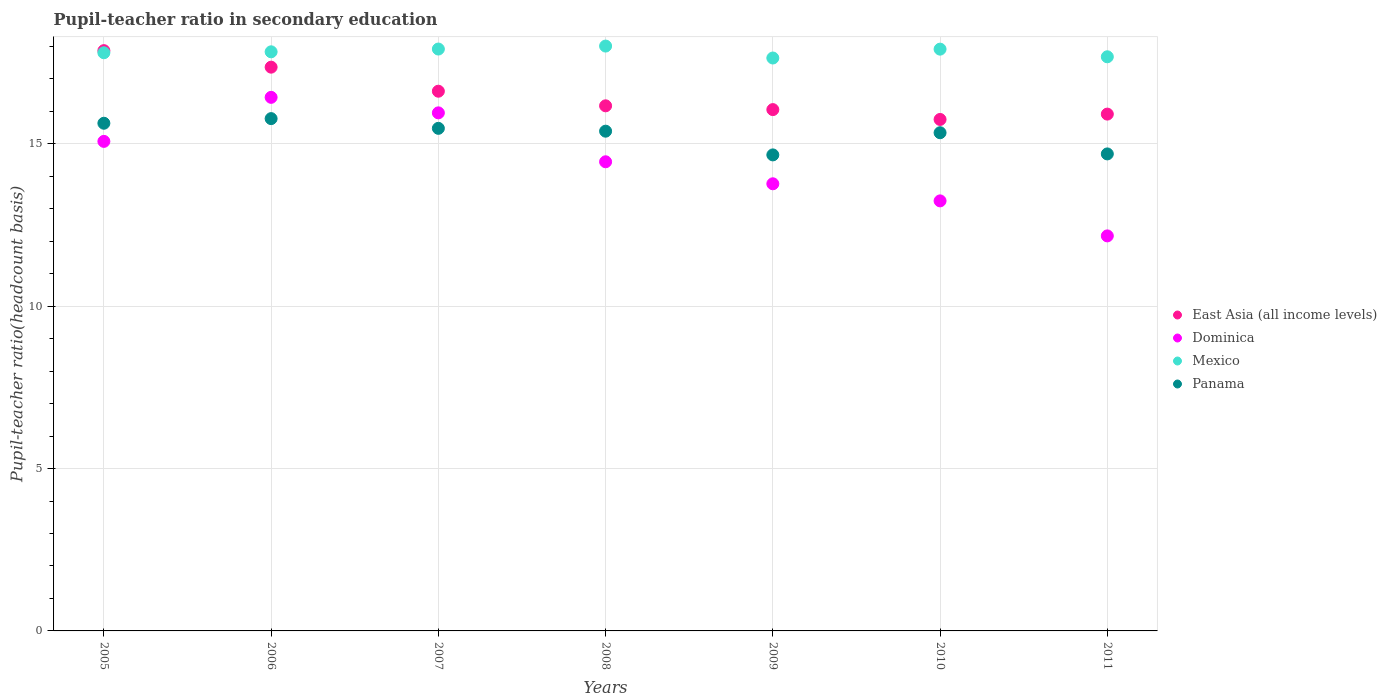What is the pupil-teacher ratio in secondary education in Dominica in 2005?
Offer a very short reply. 15.07. Across all years, what is the maximum pupil-teacher ratio in secondary education in Dominica?
Your answer should be very brief. 16.43. Across all years, what is the minimum pupil-teacher ratio in secondary education in Mexico?
Offer a very short reply. 17.64. What is the total pupil-teacher ratio in secondary education in Mexico in the graph?
Your answer should be very brief. 124.78. What is the difference between the pupil-teacher ratio in secondary education in East Asia (all income levels) in 2008 and that in 2011?
Your response must be concise. 0.26. What is the difference between the pupil-teacher ratio in secondary education in Dominica in 2006 and the pupil-teacher ratio in secondary education in Mexico in 2011?
Make the answer very short. -1.25. What is the average pupil-teacher ratio in secondary education in Dominica per year?
Your answer should be compact. 14.44. In the year 2010, what is the difference between the pupil-teacher ratio in secondary education in Dominica and pupil-teacher ratio in secondary education in Mexico?
Provide a succinct answer. -4.67. In how many years, is the pupil-teacher ratio in secondary education in Panama greater than 4?
Your response must be concise. 7. What is the ratio of the pupil-teacher ratio in secondary education in Dominica in 2007 to that in 2009?
Offer a terse response. 1.16. Is the pupil-teacher ratio in secondary education in Panama in 2008 less than that in 2011?
Your answer should be compact. No. Is the difference between the pupil-teacher ratio in secondary education in Dominica in 2008 and 2010 greater than the difference between the pupil-teacher ratio in secondary education in Mexico in 2008 and 2010?
Offer a terse response. Yes. What is the difference between the highest and the second highest pupil-teacher ratio in secondary education in East Asia (all income levels)?
Keep it short and to the point. 0.51. What is the difference between the highest and the lowest pupil-teacher ratio in secondary education in Mexico?
Offer a very short reply. 0.37. In how many years, is the pupil-teacher ratio in secondary education in Dominica greater than the average pupil-teacher ratio in secondary education in Dominica taken over all years?
Give a very brief answer. 4. Is it the case that in every year, the sum of the pupil-teacher ratio in secondary education in Dominica and pupil-teacher ratio in secondary education in East Asia (all income levels)  is greater than the sum of pupil-teacher ratio in secondary education in Mexico and pupil-teacher ratio in secondary education in Panama?
Offer a terse response. No. Does the pupil-teacher ratio in secondary education in Mexico monotonically increase over the years?
Your answer should be very brief. No. Is the pupil-teacher ratio in secondary education in Dominica strictly less than the pupil-teacher ratio in secondary education in East Asia (all income levels) over the years?
Offer a terse response. Yes. How many dotlines are there?
Offer a terse response. 4. Where does the legend appear in the graph?
Make the answer very short. Center right. What is the title of the graph?
Provide a short and direct response. Pupil-teacher ratio in secondary education. Does "Congo (Republic)" appear as one of the legend labels in the graph?
Your response must be concise. No. What is the label or title of the X-axis?
Keep it short and to the point. Years. What is the label or title of the Y-axis?
Provide a short and direct response. Pupil-teacher ratio(headcount basis). What is the Pupil-teacher ratio(headcount basis) in East Asia (all income levels) in 2005?
Your answer should be compact. 17.87. What is the Pupil-teacher ratio(headcount basis) of Dominica in 2005?
Ensure brevity in your answer.  15.07. What is the Pupil-teacher ratio(headcount basis) of Mexico in 2005?
Provide a succinct answer. 17.8. What is the Pupil-teacher ratio(headcount basis) of Panama in 2005?
Your answer should be compact. 15.63. What is the Pupil-teacher ratio(headcount basis) in East Asia (all income levels) in 2006?
Ensure brevity in your answer.  17.36. What is the Pupil-teacher ratio(headcount basis) in Dominica in 2006?
Your response must be concise. 16.43. What is the Pupil-teacher ratio(headcount basis) of Mexico in 2006?
Make the answer very short. 17.83. What is the Pupil-teacher ratio(headcount basis) in Panama in 2006?
Provide a succinct answer. 15.77. What is the Pupil-teacher ratio(headcount basis) in East Asia (all income levels) in 2007?
Provide a short and direct response. 16.62. What is the Pupil-teacher ratio(headcount basis) of Dominica in 2007?
Ensure brevity in your answer.  15.95. What is the Pupil-teacher ratio(headcount basis) in Mexico in 2007?
Give a very brief answer. 17.92. What is the Pupil-teacher ratio(headcount basis) of Panama in 2007?
Make the answer very short. 15.47. What is the Pupil-teacher ratio(headcount basis) in East Asia (all income levels) in 2008?
Your answer should be compact. 16.17. What is the Pupil-teacher ratio(headcount basis) of Dominica in 2008?
Keep it short and to the point. 14.44. What is the Pupil-teacher ratio(headcount basis) in Mexico in 2008?
Ensure brevity in your answer.  18.01. What is the Pupil-teacher ratio(headcount basis) of Panama in 2008?
Your response must be concise. 15.39. What is the Pupil-teacher ratio(headcount basis) of East Asia (all income levels) in 2009?
Ensure brevity in your answer.  16.05. What is the Pupil-teacher ratio(headcount basis) in Dominica in 2009?
Make the answer very short. 13.77. What is the Pupil-teacher ratio(headcount basis) of Mexico in 2009?
Make the answer very short. 17.64. What is the Pupil-teacher ratio(headcount basis) in Panama in 2009?
Provide a succinct answer. 14.66. What is the Pupil-teacher ratio(headcount basis) of East Asia (all income levels) in 2010?
Your answer should be very brief. 15.75. What is the Pupil-teacher ratio(headcount basis) in Dominica in 2010?
Offer a very short reply. 13.24. What is the Pupil-teacher ratio(headcount basis) in Mexico in 2010?
Make the answer very short. 17.91. What is the Pupil-teacher ratio(headcount basis) in Panama in 2010?
Provide a short and direct response. 15.34. What is the Pupil-teacher ratio(headcount basis) of East Asia (all income levels) in 2011?
Make the answer very short. 15.91. What is the Pupil-teacher ratio(headcount basis) in Dominica in 2011?
Keep it short and to the point. 12.16. What is the Pupil-teacher ratio(headcount basis) of Mexico in 2011?
Keep it short and to the point. 17.68. What is the Pupil-teacher ratio(headcount basis) of Panama in 2011?
Offer a very short reply. 14.69. Across all years, what is the maximum Pupil-teacher ratio(headcount basis) of East Asia (all income levels)?
Give a very brief answer. 17.87. Across all years, what is the maximum Pupil-teacher ratio(headcount basis) of Dominica?
Keep it short and to the point. 16.43. Across all years, what is the maximum Pupil-teacher ratio(headcount basis) in Mexico?
Provide a short and direct response. 18.01. Across all years, what is the maximum Pupil-teacher ratio(headcount basis) of Panama?
Provide a succinct answer. 15.77. Across all years, what is the minimum Pupil-teacher ratio(headcount basis) of East Asia (all income levels)?
Offer a terse response. 15.75. Across all years, what is the minimum Pupil-teacher ratio(headcount basis) in Dominica?
Ensure brevity in your answer.  12.16. Across all years, what is the minimum Pupil-teacher ratio(headcount basis) of Mexico?
Your answer should be very brief. 17.64. Across all years, what is the minimum Pupil-teacher ratio(headcount basis) in Panama?
Your answer should be compact. 14.66. What is the total Pupil-teacher ratio(headcount basis) of East Asia (all income levels) in the graph?
Make the answer very short. 115.72. What is the total Pupil-teacher ratio(headcount basis) of Dominica in the graph?
Offer a terse response. 101.07. What is the total Pupil-teacher ratio(headcount basis) of Mexico in the graph?
Make the answer very short. 124.78. What is the total Pupil-teacher ratio(headcount basis) in Panama in the graph?
Provide a short and direct response. 106.95. What is the difference between the Pupil-teacher ratio(headcount basis) of East Asia (all income levels) in 2005 and that in 2006?
Keep it short and to the point. 0.51. What is the difference between the Pupil-teacher ratio(headcount basis) of Dominica in 2005 and that in 2006?
Offer a very short reply. -1.36. What is the difference between the Pupil-teacher ratio(headcount basis) of Mexico in 2005 and that in 2006?
Make the answer very short. -0.03. What is the difference between the Pupil-teacher ratio(headcount basis) in Panama in 2005 and that in 2006?
Give a very brief answer. -0.14. What is the difference between the Pupil-teacher ratio(headcount basis) of East Asia (all income levels) in 2005 and that in 2007?
Make the answer very short. 1.25. What is the difference between the Pupil-teacher ratio(headcount basis) in Dominica in 2005 and that in 2007?
Your response must be concise. -0.88. What is the difference between the Pupil-teacher ratio(headcount basis) of Mexico in 2005 and that in 2007?
Provide a succinct answer. -0.11. What is the difference between the Pupil-teacher ratio(headcount basis) in Panama in 2005 and that in 2007?
Your answer should be very brief. 0.16. What is the difference between the Pupil-teacher ratio(headcount basis) of East Asia (all income levels) in 2005 and that in 2008?
Give a very brief answer. 1.7. What is the difference between the Pupil-teacher ratio(headcount basis) of Dominica in 2005 and that in 2008?
Ensure brevity in your answer.  0.63. What is the difference between the Pupil-teacher ratio(headcount basis) of Mexico in 2005 and that in 2008?
Offer a very short reply. -0.21. What is the difference between the Pupil-teacher ratio(headcount basis) of Panama in 2005 and that in 2008?
Keep it short and to the point. 0.24. What is the difference between the Pupil-teacher ratio(headcount basis) of East Asia (all income levels) in 2005 and that in 2009?
Your response must be concise. 1.82. What is the difference between the Pupil-teacher ratio(headcount basis) in Dominica in 2005 and that in 2009?
Your response must be concise. 1.31. What is the difference between the Pupil-teacher ratio(headcount basis) of Mexico in 2005 and that in 2009?
Your response must be concise. 0.16. What is the difference between the Pupil-teacher ratio(headcount basis) in Panama in 2005 and that in 2009?
Ensure brevity in your answer.  0.97. What is the difference between the Pupil-teacher ratio(headcount basis) of East Asia (all income levels) in 2005 and that in 2010?
Ensure brevity in your answer.  2.12. What is the difference between the Pupil-teacher ratio(headcount basis) of Dominica in 2005 and that in 2010?
Provide a succinct answer. 1.83. What is the difference between the Pupil-teacher ratio(headcount basis) in Mexico in 2005 and that in 2010?
Provide a succinct answer. -0.11. What is the difference between the Pupil-teacher ratio(headcount basis) in Panama in 2005 and that in 2010?
Ensure brevity in your answer.  0.29. What is the difference between the Pupil-teacher ratio(headcount basis) of East Asia (all income levels) in 2005 and that in 2011?
Ensure brevity in your answer.  1.95. What is the difference between the Pupil-teacher ratio(headcount basis) in Dominica in 2005 and that in 2011?
Your answer should be very brief. 2.91. What is the difference between the Pupil-teacher ratio(headcount basis) in Mexico in 2005 and that in 2011?
Keep it short and to the point. 0.12. What is the difference between the Pupil-teacher ratio(headcount basis) in Panama in 2005 and that in 2011?
Make the answer very short. 0.94. What is the difference between the Pupil-teacher ratio(headcount basis) of East Asia (all income levels) in 2006 and that in 2007?
Offer a very short reply. 0.74. What is the difference between the Pupil-teacher ratio(headcount basis) of Dominica in 2006 and that in 2007?
Your answer should be very brief. 0.48. What is the difference between the Pupil-teacher ratio(headcount basis) of Mexico in 2006 and that in 2007?
Ensure brevity in your answer.  -0.09. What is the difference between the Pupil-teacher ratio(headcount basis) in Panama in 2006 and that in 2007?
Offer a terse response. 0.3. What is the difference between the Pupil-teacher ratio(headcount basis) in East Asia (all income levels) in 2006 and that in 2008?
Your answer should be very brief. 1.19. What is the difference between the Pupil-teacher ratio(headcount basis) in Dominica in 2006 and that in 2008?
Offer a terse response. 1.98. What is the difference between the Pupil-teacher ratio(headcount basis) in Mexico in 2006 and that in 2008?
Make the answer very short. -0.18. What is the difference between the Pupil-teacher ratio(headcount basis) in Panama in 2006 and that in 2008?
Provide a succinct answer. 0.39. What is the difference between the Pupil-teacher ratio(headcount basis) in East Asia (all income levels) in 2006 and that in 2009?
Make the answer very short. 1.31. What is the difference between the Pupil-teacher ratio(headcount basis) of Dominica in 2006 and that in 2009?
Keep it short and to the point. 2.66. What is the difference between the Pupil-teacher ratio(headcount basis) of Mexico in 2006 and that in 2009?
Your answer should be very brief. 0.19. What is the difference between the Pupil-teacher ratio(headcount basis) of Panama in 2006 and that in 2009?
Give a very brief answer. 1.12. What is the difference between the Pupil-teacher ratio(headcount basis) in East Asia (all income levels) in 2006 and that in 2010?
Provide a succinct answer. 1.61. What is the difference between the Pupil-teacher ratio(headcount basis) of Dominica in 2006 and that in 2010?
Your response must be concise. 3.19. What is the difference between the Pupil-teacher ratio(headcount basis) of Mexico in 2006 and that in 2010?
Ensure brevity in your answer.  -0.08. What is the difference between the Pupil-teacher ratio(headcount basis) of Panama in 2006 and that in 2010?
Provide a succinct answer. 0.43. What is the difference between the Pupil-teacher ratio(headcount basis) in East Asia (all income levels) in 2006 and that in 2011?
Give a very brief answer. 1.45. What is the difference between the Pupil-teacher ratio(headcount basis) in Dominica in 2006 and that in 2011?
Offer a very short reply. 4.27. What is the difference between the Pupil-teacher ratio(headcount basis) in Mexico in 2006 and that in 2011?
Provide a succinct answer. 0.15. What is the difference between the Pupil-teacher ratio(headcount basis) in Panama in 2006 and that in 2011?
Your response must be concise. 1.09. What is the difference between the Pupil-teacher ratio(headcount basis) in East Asia (all income levels) in 2007 and that in 2008?
Provide a succinct answer. 0.45. What is the difference between the Pupil-teacher ratio(headcount basis) of Dominica in 2007 and that in 2008?
Your answer should be compact. 1.51. What is the difference between the Pupil-teacher ratio(headcount basis) of Mexico in 2007 and that in 2008?
Offer a terse response. -0.09. What is the difference between the Pupil-teacher ratio(headcount basis) in Panama in 2007 and that in 2008?
Provide a short and direct response. 0.09. What is the difference between the Pupil-teacher ratio(headcount basis) in East Asia (all income levels) in 2007 and that in 2009?
Offer a very short reply. 0.57. What is the difference between the Pupil-teacher ratio(headcount basis) in Dominica in 2007 and that in 2009?
Your answer should be compact. 2.18. What is the difference between the Pupil-teacher ratio(headcount basis) of Mexico in 2007 and that in 2009?
Offer a very short reply. 0.28. What is the difference between the Pupil-teacher ratio(headcount basis) in Panama in 2007 and that in 2009?
Provide a short and direct response. 0.82. What is the difference between the Pupil-teacher ratio(headcount basis) in East Asia (all income levels) in 2007 and that in 2010?
Ensure brevity in your answer.  0.87. What is the difference between the Pupil-teacher ratio(headcount basis) in Dominica in 2007 and that in 2010?
Provide a succinct answer. 2.71. What is the difference between the Pupil-teacher ratio(headcount basis) in Mexico in 2007 and that in 2010?
Your response must be concise. 0. What is the difference between the Pupil-teacher ratio(headcount basis) in Panama in 2007 and that in 2010?
Give a very brief answer. 0.14. What is the difference between the Pupil-teacher ratio(headcount basis) of East Asia (all income levels) in 2007 and that in 2011?
Offer a terse response. 0.7. What is the difference between the Pupil-teacher ratio(headcount basis) of Dominica in 2007 and that in 2011?
Make the answer very short. 3.79. What is the difference between the Pupil-teacher ratio(headcount basis) of Mexico in 2007 and that in 2011?
Give a very brief answer. 0.24. What is the difference between the Pupil-teacher ratio(headcount basis) in Panama in 2007 and that in 2011?
Make the answer very short. 0.79. What is the difference between the Pupil-teacher ratio(headcount basis) of East Asia (all income levels) in 2008 and that in 2009?
Your answer should be compact. 0.12. What is the difference between the Pupil-teacher ratio(headcount basis) in Dominica in 2008 and that in 2009?
Your answer should be very brief. 0.68. What is the difference between the Pupil-teacher ratio(headcount basis) in Mexico in 2008 and that in 2009?
Offer a terse response. 0.37. What is the difference between the Pupil-teacher ratio(headcount basis) in Panama in 2008 and that in 2009?
Your response must be concise. 0.73. What is the difference between the Pupil-teacher ratio(headcount basis) in East Asia (all income levels) in 2008 and that in 2010?
Your response must be concise. 0.42. What is the difference between the Pupil-teacher ratio(headcount basis) in Dominica in 2008 and that in 2010?
Offer a terse response. 1.2. What is the difference between the Pupil-teacher ratio(headcount basis) of Mexico in 2008 and that in 2010?
Provide a short and direct response. 0.09. What is the difference between the Pupil-teacher ratio(headcount basis) in Panama in 2008 and that in 2010?
Make the answer very short. 0.05. What is the difference between the Pupil-teacher ratio(headcount basis) in East Asia (all income levels) in 2008 and that in 2011?
Your answer should be compact. 0.26. What is the difference between the Pupil-teacher ratio(headcount basis) of Dominica in 2008 and that in 2011?
Provide a short and direct response. 2.28. What is the difference between the Pupil-teacher ratio(headcount basis) in Mexico in 2008 and that in 2011?
Provide a short and direct response. 0.33. What is the difference between the Pupil-teacher ratio(headcount basis) in Panama in 2008 and that in 2011?
Provide a succinct answer. 0.7. What is the difference between the Pupil-teacher ratio(headcount basis) in East Asia (all income levels) in 2009 and that in 2010?
Your answer should be compact. 0.3. What is the difference between the Pupil-teacher ratio(headcount basis) in Dominica in 2009 and that in 2010?
Your answer should be compact. 0.53. What is the difference between the Pupil-teacher ratio(headcount basis) in Mexico in 2009 and that in 2010?
Offer a very short reply. -0.27. What is the difference between the Pupil-teacher ratio(headcount basis) in Panama in 2009 and that in 2010?
Give a very brief answer. -0.68. What is the difference between the Pupil-teacher ratio(headcount basis) in East Asia (all income levels) in 2009 and that in 2011?
Your answer should be compact. 0.14. What is the difference between the Pupil-teacher ratio(headcount basis) in Dominica in 2009 and that in 2011?
Provide a short and direct response. 1.6. What is the difference between the Pupil-teacher ratio(headcount basis) in Mexico in 2009 and that in 2011?
Provide a succinct answer. -0.04. What is the difference between the Pupil-teacher ratio(headcount basis) of Panama in 2009 and that in 2011?
Your answer should be very brief. -0.03. What is the difference between the Pupil-teacher ratio(headcount basis) in East Asia (all income levels) in 2010 and that in 2011?
Give a very brief answer. -0.16. What is the difference between the Pupil-teacher ratio(headcount basis) in Dominica in 2010 and that in 2011?
Your response must be concise. 1.08. What is the difference between the Pupil-teacher ratio(headcount basis) of Mexico in 2010 and that in 2011?
Your response must be concise. 0.24. What is the difference between the Pupil-teacher ratio(headcount basis) in Panama in 2010 and that in 2011?
Offer a very short reply. 0.65. What is the difference between the Pupil-teacher ratio(headcount basis) in East Asia (all income levels) in 2005 and the Pupil-teacher ratio(headcount basis) in Dominica in 2006?
Offer a very short reply. 1.44. What is the difference between the Pupil-teacher ratio(headcount basis) in East Asia (all income levels) in 2005 and the Pupil-teacher ratio(headcount basis) in Mexico in 2006?
Provide a short and direct response. 0.04. What is the difference between the Pupil-teacher ratio(headcount basis) in East Asia (all income levels) in 2005 and the Pupil-teacher ratio(headcount basis) in Panama in 2006?
Give a very brief answer. 2.09. What is the difference between the Pupil-teacher ratio(headcount basis) in Dominica in 2005 and the Pupil-teacher ratio(headcount basis) in Mexico in 2006?
Keep it short and to the point. -2.76. What is the difference between the Pupil-teacher ratio(headcount basis) of Dominica in 2005 and the Pupil-teacher ratio(headcount basis) of Panama in 2006?
Keep it short and to the point. -0.7. What is the difference between the Pupil-teacher ratio(headcount basis) in Mexico in 2005 and the Pupil-teacher ratio(headcount basis) in Panama in 2006?
Offer a terse response. 2.03. What is the difference between the Pupil-teacher ratio(headcount basis) of East Asia (all income levels) in 2005 and the Pupil-teacher ratio(headcount basis) of Dominica in 2007?
Make the answer very short. 1.92. What is the difference between the Pupil-teacher ratio(headcount basis) of East Asia (all income levels) in 2005 and the Pupil-teacher ratio(headcount basis) of Mexico in 2007?
Make the answer very short. -0.05. What is the difference between the Pupil-teacher ratio(headcount basis) of East Asia (all income levels) in 2005 and the Pupil-teacher ratio(headcount basis) of Panama in 2007?
Your answer should be very brief. 2.39. What is the difference between the Pupil-teacher ratio(headcount basis) in Dominica in 2005 and the Pupil-teacher ratio(headcount basis) in Mexico in 2007?
Your answer should be very brief. -2.84. What is the difference between the Pupil-teacher ratio(headcount basis) of Dominica in 2005 and the Pupil-teacher ratio(headcount basis) of Panama in 2007?
Your answer should be compact. -0.4. What is the difference between the Pupil-teacher ratio(headcount basis) in Mexico in 2005 and the Pupil-teacher ratio(headcount basis) in Panama in 2007?
Offer a very short reply. 2.33. What is the difference between the Pupil-teacher ratio(headcount basis) of East Asia (all income levels) in 2005 and the Pupil-teacher ratio(headcount basis) of Dominica in 2008?
Make the answer very short. 3.42. What is the difference between the Pupil-teacher ratio(headcount basis) of East Asia (all income levels) in 2005 and the Pupil-teacher ratio(headcount basis) of Mexico in 2008?
Your answer should be very brief. -0.14. What is the difference between the Pupil-teacher ratio(headcount basis) of East Asia (all income levels) in 2005 and the Pupil-teacher ratio(headcount basis) of Panama in 2008?
Make the answer very short. 2.48. What is the difference between the Pupil-teacher ratio(headcount basis) of Dominica in 2005 and the Pupil-teacher ratio(headcount basis) of Mexico in 2008?
Offer a terse response. -2.93. What is the difference between the Pupil-teacher ratio(headcount basis) of Dominica in 2005 and the Pupil-teacher ratio(headcount basis) of Panama in 2008?
Give a very brief answer. -0.31. What is the difference between the Pupil-teacher ratio(headcount basis) in Mexico in 2005 and the Pupil-teacher ratio(headcount basis) in Panama in 2008?
Provide a succinct answer. 2.41. What is the difference between the Pupil-teacher ratio(headcount basis) in East Asia (all income levels) in 2005 and the Pupil-teacher ratio(headcount basis) in Dominica in 2009?
Keep it short and to the point. 4.1. What is the difference between the Pupil-teacher ratio(headcount basis) of East Asia (all income levels) in 2005 and the Pupil-teacher ratio(headcount basis) of Mexico in 2009?
Give a very brief answer. 0.23. What is the difference between the Pupil-teacher ratio(headcount basis) of East Asia (all income levels) in 2005 and the Pupil-teacher ratio(headcount basis) of Panama in 2009?
Offer a very short reply. 3.21. What is the difference between the Pupil-teacher ratio(headcount basis) of Dominica in 2005 and the Pupil-teacher ratio(headcount basis) of Mexico in 2009?
Make the answer very short. -2.57. What is the difference between the Pupil-teacher ratio(headcount basis) in Dominica in 2005 and the Pupil-teacher ratio(headcount basis) in Panama in 2009?
Your answer should be compact. 0.42. What is the difference between the Pupil-teacher ratio(headcount basis) of Mexico in 2005 and the Pupil-teacher ratio(headcount basis) of Panama in 2009?
Your answer should be very brief. 3.15. What is the difference between the Pupil-teacher ratio(headcount basis) of East Asia (all income levels) in 2005 and the Pupil-teacher ratio(headcount basis) of Dominica in 2010?
Provide a succinct answer. 4.63. What is the difference between the Pupil-teacher ratio(headcount basis) of East Asia (all income levels) in 2005 and the Pupil-teacher ratio(headcount basis) of Mexico in 2010?
Provide a short and direct response. -0.05. What is the difference between the Pupil-teacher ratio(headcount basis) of East Asia (all income levels) in 2005 and the Pupil-teacher ratio(headcount basis) of Panama in 2010?
Make the answer very short. 2.53. What is the difference between the Pupil-teacher ratio(headcount basis) of Dominica in 2005 and the Pupil-teacher ratio(headcount basis) of Mexico in 2010?
Ensure brevity in your answer.  -2.84. What is the difference between the Pupil-teacher ratio(headcount basis) of Dominica in 2005 and the Pupil-teacher ratio(headcount basis) of Panama in 2010?
Your answer should be compact. -0.27. What is the difference between the Pupil-teacher ratio(headcount basis) in Mexico in 2005 and the Pupil-teacher ratio(headcount basis) in Panama in 2010?
Ensure brevity in your answer.  2.46. What is the difference between the Pupil-teacher ratio(headcount basis) in East Asia (all income levels) in 2005 and the Pupil-teacher ratio(headcount basis) in Dominica in 2011?
Give a very brief answer. 5.7. What is the difference between the Pupil-teacher ratio(headcount basis) in East Asia (all income levels) in 2005 and the Pupil-teacher ratio(headcount basis) in Mexico in 2011?
Your response must be concise. 0.19. What is the difference between the Pupil-teacher ratio(headcount basis) in East Asia (all income levels) in 2005 and the Pupil-teacher ratio(headcount basis) in Panama in 2011?
Give a very brief answer. 3.18. What is the difference between the Pupil-teacher ratio(headcount basis) of Dominica in 2005 and the Pupil-teacher ratio(headcount basis) of Mexico in 2011?
Your answer should be compact. -2.6. What is the difference between the Pupil-teacher ratio(headcount basis) in Dominica in 2005 and the Pupil-teacher ratio(headcount basis) in Panama in 2011?
Offer a terse response. 0.39. What is the difference between the Pupil-teacher ratio(headcount basis) of Mexico in 2005 and the Pupil-teacher ratio(headcount basis) of Panama in 2011?
Offer a very short reply. 3.12. What is the difference between the Pupil-teacher ratio(headcount basis) in East Asia (all income levels) in 2006 and the Pupil-teacher ratio(headcount basis) in Dominica in 2007?
Keep it short and to the point. 1.41. What is the difference between the Pupil-teacher ratio(headcount basis) in East Asia (all income levels) in 2006 and the Pupil-teacher ratio(headcount basis) in Mexico in 2007?
Offer a terse response. -0.56. What is the difference between the Pupil-teacher ratio(headcount basis) in East Asia (all income levels) in 2006 and the Pupil-teacher ratio(headcount basis) in Panama in 2007?
Your answer should be compact. 1.88. What is the difference between the Pupil-teacher ratio(headcount basis) of Dominica in 2006 and the Pupil-teacher ratio(headcount basis) of Mexico in 2007?
Provide a succinct answer. -1.49. What is the difference between the Pupil-teacher ratio(headcount basis) of Dominica in 2006 and the Pupil-teacher ratio(headcount basis) of Panama in 2007?
Offer a very short reply. 0.95. What is the difference between the Pupil-teacher ratio(headcount basis) in Mexico in 2006 and the Pupil-teacher ratio(headcount basis) in Panama in 2007?
Provide a short and direct response. 2.36. What is the difference between the Pupil-teacher ratio(headcount basis) of East Asia (all income levels) in 2006 and the Pupil-teacher ratio(headcount basis) of Dominica in 2008?
Provide a succinct answer. 2.91. What is the difference between the Pupil-teacher ratio(headcount basis) in East Asia (all income levels) in 2006 and the Pupil-teacher ratio(headcount basis) in Mexico in 2008?
Offer a terse response. -0.65. What is the difference between the Pupil-teacher ratio(headcount basis) in East Asia (all income levels) in 2006 and the Pupil-teacher ratio(headcount basis) in Panama in 2008?
Make the answer very short. 1.97. What is the difference between the Pupil-teacher ratio(headcount basis) of Dominica in 2006 and the Pupil-teacher ratio(headcount basis) of Mexico in 2008?
Ensure brevity in your answer.  -1.58. What is the difference between the Pupil-teacher ratio(headcount basis) of Dominica in 2006 and the Pupil-teacher ratio(headcount basis) of Panama in 2008?
Give a very brief answer. 1.04. What is the difference between the Pupil-teacher ratio(headcount basis) of Mexico in 2006 and the Pupil-teacher ratio(headcount basis) of Panama in 2008?
Make the answer very short. 2.44. What is the difference between the Pupil-teacher ratio(headcount basis) in East Asia (all income levels) in 2006 and the Pupil-teacher ratio(headcount basis) in Dominica in 2009?
Give a very brief answer. 3.59. What is the difference between the Pupil-teacher ratio(headcount basis) in East Asia (all income levels) in 2006 and the Pupil-teacher ratio(headcount basis) in Mexico in 2009?
Offer a terse response. -0.28. What is the difference between the Pupil-teacher ratio(headcount basis) of East Asia (all income levels) in 2006 and the Pupil-teacher ratio(headcount basis) of Panama in 2009?
Your response must be concise. 2.7. What is the difference between the Pupil-teacher ratio(headcount basis) in Dominica in 2006 and the Pupil-teacher ratio(headcount basis) in Mexico in 2009?
Offer a very short reply. -1.21. What is the difference between the Pupil-teacher ratio(headcount basis) of Dominica in 2006 and the Pupil-teacher ratio(headcount basis) of Panama in 2009?
Keep it short and to the point. 1.77. What is the difference between the Pupil-teacher ratio(headcount basis) in Mexico in 2006 and the Pupil-teacher ratio(headcount basis) in Panama in 2009?
Offer a terse response. 3.17. What is the difference between the Pupil-teacher ratio(headcount basis) in East Asia (all income levels) in 2006 and the Pupil-teacher ratio(headcount basis) in Dominica in 2010?
Your answer should be very brief. 4.12. What is the difference between the Pupil-teacher ratio(headcount basis) in East Asia (all income levels) in 2006 and the Pupil-teacher ratio(headcount basis) in Mexico in 2010?
Give a very brief answer. -0.55. What is the difference between the Pupil-teacher ratio(headcount basis) in East Asia (all income levels) in 2006 and the Pupil-teacher ratio(headcount basis) in Panama in 2010?
Keep it short and to the point. 2.02. What is the difference between the Pupil-teacher ratio(headcount basis) of Dominica in 2006 and the Pupil-teacher ratio(headcount basis) of Mexico in 2010?
Keep it short and to the point. -1.48. What is the difference between the Pupil-teacher ratio(headcount basis) in Dominica in 2006 and the Pupil-teacher ratio(headcount basis) in Panama in 2010?
Give a very brief answer. 1.09. What is the difference between the Pupil-teacher ratio(headcount basis) in Mexico in 2006 and the Pupil-teacher ratio(headcount basis) in Panama in 2010?
Your answer should be compact. 2.49. What is the difference between the Pupil-teacher ratio(headcount basis) of East Asia (all income levels) in 2006 and the Pupil-teacher ratio(headcount basis) of Dominica in 2011?
Ensure brevity in your answer.  5.2. What is the difference between the Pupil-teacher ratio(headcount basis) of East Asia (all income levels) in 2006 and the Pupil-teacher ratio(headcount basis) of Mexico in 2011?
Your answer should be compact. -0.32. What is the difference between the Pupil-teacher ratio(headcount basis) of East Asia (all income levels) in 2006 and the Pupil-teacher ratio(headcount basis) of Panama in 2011?
Ensure brevity in your answer.  2.67. What is the difference between the Pupil-teacher ratio(headcount basis) in Dominica in 2006 and the Pupil-teacher ratio(headcount basis) in Mexico in 2011?
Your answer should be very brief. -1.25. What is the difference between the Pupil-teacher ratio(headcount basis) in Dominica in 2006 and the Pupil-teacher ratio(headcount basis) in Panama in 2011?
Give a very brief answer. 1.74. What is the difference between the Pupil-teacher ratio(headcount basis) of Mexico in 2006 and the Pupil-teacher ratio(headcount basis) of Panama in 2011?
Provide a short and direct response. 3.14. What is the difference between the Pupil-teacher ratio(headcount basis) of East Asia (all income levels) in 2007 and the Pupil-teacher ratio(headcount basis) of Dominica in 2008?
Keep it short and to the point. 2.17. What is the difference between the Pupil-teacher ratio(headcount basis) of East Asia (all income levels) in 2007 and the Pupil-teacher ratio(headcount basis) of Mexico in 2008?
Make the answer very short. -1.39. What is the difference between the Pupil-teacher ratio(headcount basis) in East Asia (all income levels) in 2007 and the Pupil-teacher ratio(headcount basis) in Panama in 2008?
Ensure brevity in your answer.  1.23. What is the difference between the Pupil-teacher ratio(headcount basis) in Dominica in 2007 and the Pupil-teacher ratio(headcount basis) in Mexico in 2008?
Ensure brevity in your answer.  -2.06. What is the difference between the Pupil-teacher ratio(headcount basis) of Dominica in 2007 and the Pupil-teacher ratio(headcount basis) of Panama in 2008?
Keep it short and to the point. 0.56. What is the difference between the Pupil-teacher ratio(headcount basis) in Mexico in 2007 and the Pupil-teacher ratio(headcount basis) in Panama in 2008?
Offer a very short reply. 2.53. What is the difference between the Pupil-teacher ratio(headcount basis) in East Asia (all income levels) in 2007 and the Pupil-teacher ratio(headcount basis) in Dominica in 2009?
Provide a short and direct response. 2.85. What is the difference between the Pupil-teacher ratio(headcount basis) of East Asia (all income levels) in 2007 and the Pupil-teacher ratio(headcount basis) of Mexico in 2009?
Make the answer very short. -1.02. What is the difference between the Pupil-teacher ratio(headcount basis) in East Asia (all income levels) in 2007 and the Pupil-teacher ratio(headcount basis) in Panama in 2009?
Your answer should be compact. 1.96. What is the difference between the Pupil-teacher ratio(headcount basis) of Dominica in 2007 and the Pupil-teacher ratio(headcount basis) of Mexico in 2009?
Your answer should be very brief. -1.69. What is the difference between the Pupil-teacher ratio(headcount basis) in Dominica in 2007 and the Pupil-teacher ratio(headcount basis) in Panama in 2009?
Offer a very short reply. 1.29. What is the difference between the Pupil-teacher ratio(headcount basis) in Mexico in 2007 and the Pupil-teacher ratio(headcount basis) in Panama in 2009?
Ensure brevity in your answer.  3.26. What is the difference between the Pupil-teacher ratio(headcount basis) in East Asia (all income levels) in 2007 and the Pupil-teacher ratio(headcount basis) in Dominica in 2010?
Offer a terse response. 3.38. What is the difference between the Pupil-teacher ratio(headcount basis) in East Asia (all income levels) in 2007 and the Pupil-teacher ratio(headcount basis) in Mexico in 2010?
Offer a terse response. -1.3. What is the difference between the Pupil-teacher ratio(headcount basis) of East Asia (all income levels) in 2007 and the Pupil-teacher ratio(headcount basis) of Panama in 2010?
Ensure brevity in your answer.  1.28. What is the difference between the Pupil-teacher ratio(headcount basis) of Dominica in 2007 and the Pupil-teacher ratio(headcount basis) of Mexico in 2010?
Make the answer very short. -1.96. What is the difference between the Pupil-teacher ratio(headcount basis) of Dominica in 2007 and the Pupil-teacher ratio(headcount basis) of Panama in 2010?
Ensure brevity in your answer.  0.61. What is the difference between the Pupil-teacher ratio(headcount basis) in Mexico in 2007 and the Pupil-teacher ratio(headcount basis) in Panama in 2010?
Offer a terse response. 2.58. What is the difference between the Pupil-teacher ratio(headcount basis) of East Asia (all income levels) in 2007 and the Pupil-teacher ratio(headcount basis) of Dominica in 2011?
Offer a very short reply. 4.45. What is the difference between the Pupil-teacher ratio(headcount basis) in East Asia (all income levels) in 2007 and the Pupil-teacher ratio(headcount basis) in Mexico in 2011?
Provide a succinct answer. -1.06. What is the difference between the Pupil-teacher ratio(headcount basis) in East Asia (all income levels) in 2007 and the Pupil-teacher ratio(headcount basis) in Panama in 2011?
Give a very brief answer. 1.93. What is the difference between the Pupil-teacher ratio(headcount basis) of Dominica in 2007 and the Pupil-teacher ratio(headcount basis) of Mexico in 2011?
Offer a very short reply. -1.73. What is the difference between the Pupil-teacher ratio(headcount basis) in Dominica in 2007 and the Pupil-teacher ratio(headcount basis) in Panama in 2011?
Give a very brief answer. 1.26. What is the difference between the Pupil-teacher ratio(headcount basis) in Mexico in 2007 and the Pupil-teacher ratio(headcount basis) in Panama in 2011?
Your answer should be compact. 3.23. What is the difference between the Pupil-teacher ratio(headcount basis) in East Asia (all income levels) in 2008 and the Pupil-teacher ratio(headcount basis) in Dominica in 2009?
Give a very brief answer. 2.4. What is the difference between the Pupil-teacher ratio(headcount basis) in East Asia (all income levels) in 2008 and the Pupil-teacher ratio(headcount basis) in Mexico in 2009?
Your answer should be very brief. -1.47. What is the difference between the Pupil-teacher ratio(headcount basis) in East Asia (all income levels) in 2008 and the Pupil-teacher ratio(headcount basis) in Panama in 2009?
Offer a very short reply. 1.51. What is the difference between the Pupil-teacher ratio(headcount basis) in Dominica in 2008 and the Pupil-teacher ratio(headcount basis) in Mexico in 2009?
Your answer should be very brief. -3.19. What is the difference between the Pupil-teacher ratio(headcount basis) in Dominica in 2008 and the Pupil-teacher ratio(headcount basis) in Panama in 2009?
Provide a short and direct response. -0.21. What is the difference between the Pupil-teacher ratio(headcount basis) in Mexico in 2008 and the Pupil-teacher ratio(headcount basis) in Panama in 2009?
Keep it short and to the point. 3.35. What is the difference between the Pupil-teacher ratio(headcount basis) in East Asia (all income levels) in 2008 and the Pupil-teacher ratio(headcount basis) in Dominica in 2010?
Keep it short and to the point. 2.93. What is the difference between the Pupil-teacher ratio(headcount basis) of East Asia (all income levels) in 2008 and the Pupil-teacher ratio(headcount basis) of Mexico in 2010?
Give a very brief answer. -1.74. What is the difference between the Pupil-teacher ratio(headcount basis) in East Asia (all income levels) in 2008 and the Pupil-teacher ratio(headcount basis) in Panama in 2010?
Give a very brief answer. 0.83. What is the difference between the Pupil-teacher ratio(headcount basis) of Dominica in 2008 and the Pupil-teacher ratio(headcount basis) of Mexico in 2010?
Offer a very short reply. -3.47. What is the difference between the Pupil-teacher ratio(headcount basis) of Dominica in 2008 and the Pupil-teacher ratio(headcount basis) of Panama in 2010?
Offer a very short reply. -0.89. What is the difference between the Pupil-teacher ratio(headcount basis) in Mexico in 2008 and the Pupil-teacher ratio(headcount basis) in Panama in 2010?
Provide a succinct answer. 2.67. What is the difference between the Pupil-teacher ratio(headcount basis) of East Asia (all income levels) in 2008 and the Pupil-teacher ratio(headcount basis) of Dominica in 2011?
Your answer should be compact. 4.01. What is the difference between the Pupil-teacher ratio(headcount basis) of East Asia (all income levels) in 2008 and the Pupil-teacher ratio(headcount basis) of Mexico in 2011?
Make the answer very short. -1.51. What is the difference between the Pupil-teacher ratio(headcount basis) of East Asia (all income levels) in 2008 and the Pupil-teacher ratio(headcount basis) of Panama in 2011?
Ensure brevity in your answer.  1.48. What is the difference between the Pupil-teacher ratio(headcount basis) of Dominica in 2008 and the Pupil-teacher ratio(headcount basis) of Mexico in 2011?
Offer a terse response. -3.23. What is the difference between the Pupil-teacher ratio(headcount basis) in Dominica in 2008 and the Pupil-teacher ratio(headcount basis) in Panama in 2011?
Offer a very short reply. -0.24. What is the difference between the Pupil-teacher ratio(headcount basis) of Mexico in 2008 and the Pupil-teacher ratio(headcount basis) of Panama in 2011?
Offer a terse response. 3.32. What is the difference between the Pupil-teacher ratio(headcount basis) in East Asia (all income levels) in 2009 and the Pupil-teacher ratio(headcount basis) in Dominica in 2010?
Your answer should be very brief. 2.81. What is the difference between the Pupil-teacher ratio(headcount basis) in East Asia (all income levels) in 2009 and the Pupil-teacher ratio(headcount basis) in Mexico in 2010?
Keep it short and to the point. -1.86. What is the difference between the Pupil-teacher ratio(headcount basis) in East Asia (all income levels) in 2009 and the Pupil-teacher ratio(headcount basis) in Panama in 2010?
Offer a very short reply. 0.71. What is the difference between the Pupil-teacher ratio(headcount basis) of Dominica in 2009 and the Pupil-teacher ratio(headcount basis) of Mexico in 2010?
Your answer should be compact. -4.15. What is the difference between the Pupil-teacher ratio(headcount basis) of Dominica in 2009 and the Pupil-teacher ratio(headcount basis) of Panama in 2010?
Your answer should be very brief. -1.57. What is the difference between the Pupil-teacher ratio(headcount basis) in Mexico in 2009 and the Pupil-teacher ratio(headcount basis) in Panama in 2010?
Provide a short and direct response. 2.3. What is the difference between the Pupil-teacher ratio(headcount basis) in East Asia (all income levels) in 2009 and the Pupil-teacher ratio(headcount basis) in Dominica in 2011?
Ensure brevity in your answer.  3.89. What is the difference between the Pupil-teacher ratio(headcount basis) of East Asia (all income levels) in 2009 and the Pupil-teacher ratio(headcount basis) of Mexico in 2011?
Your response must be concise. -1.63. What is the difference between the Pupil-teacher ratio(headcount basis) in East Asia (all income levels) in 2009 and the Pupil-teacher ratio(headcount basis) in Panama in 2011?
Ensure brevity in your answer.  1.36. What is the difference between the Pupil-teacher ratio(headcount basis) in Dominica in 2009 and the Pupil-teacher ratio(headcount basis) in Mexico in 2011?
Ensure brevity in your answer.  -3.91. What is the difference between the Pupil-teacher ratio(headcount basis) of Dominica in 2009 and the Pupil-teacher ratio(headcount basis) of Panama in 2011?
Your answer should be compact. -0.92. What is the difference between the Pupil-teacher ratio(headcount basis) in Mexico in 2009 and the Pupil-teacher ratio(headcount basis) in Panama in 2011?
Give a very brief answer. 2.95. What is the difference between the Pupil-teacher ratio(headcount basis) in East Asia (all income levels) in 2010 and the Pupil-teacher ratio(headcount basis) in Dominica in 2011?
Make the answer very short. 3.59. What is the difference between the Pupil-teacher ratio(headcount basis) of East Asia (all income levels) in 2010 and the Pupil-teacher ratio(headcount basis) of Mexico in 2011?
Your response must be concise. -1.93. What is the difference between the Pupil-teacher ratio(headcount basis) in East Asia (all income levels) in 2010 and the Pupil-teacher ratio(headcount basis) in Panama in 2011?
Your answer should be compact. 1.06. What is the difference between the Pupil-teacher ratio(headcount basis) in Dominica in 2010 and the Pupil-teacher ratio(headcount basis) in Mexico in 2011?
Offer a terse response. -4.44. What is the difference between the Pupil-teacher ratio(headcount basis) in Dominica in 2010 and the Pupil-teacher ratio(headcount basis) in Panama in 2011?
Provide a short and direct response. -1.45. What is the difference between the Pupil-teacher ratio(headcount basis) in Mexico in 2010 and the Pupil-teacher ratio(headcount basis) in Panama in 2011?
Offer a very short reply. 3.23. What is the average Pupil-teacher ratio(headcount basis) of East Asia (all income levels) per year?
Make the answer very short. 16.53. What is the average Pupil-teacher ratio(headcount basis) of Dominica per year?
Ensure brevity in your answer.  14.44. What is the average Pupil-teacher ratio(headcount basis) of Mexico per year?
Your response must be concise. 17.83. What is the average Pupil-teacher ratio(headcount basis) of Panama per year?
Your response must be concise. 15.28. In the year 2005, what is the difference between the Pupil-teacher ratio(headcount basis) in East Asia (all income levels) and Pupil-teacher ratio(headcount basis) in Dominica?
Ensure brevity in your answer.  2.79. In the year 2005, what is the difference between the Pupil-teacher ratio(headcount basis) of East Asia (all income levels) and Pupil-teacher ratio(headcount basis) of Mexico?
Give a very brief answer. 0.06. In the year 2005, what is the difference between the Pupil-teacher ratio(headcount basis) in East Asia (all income levels) and Pupil-teacher ratio(headcount basis) in Panama?
Make the answer very short. 2.24. In the year 2005, what is the difference between the Pupil-teacher ratio(headcount basis) in Dominica and Pupil-teacher ratio(headcount basis) in Mexico?
Your answer should be compact. -2.73. In the year 2005, what is the difference between the Pupil-teacher ratio(headcount basis) in Dominica and Pupil-teacher ratio(headcount basis) in Panama?
Provide a succinct answer. -0.56. In the year 2005, what is the difference between the Pupil-teacher ratio(headcount basis) in Mexico and Pupil-teacher ratio(headcount basis) in Panama?
Offer a very short reply. 2.17. In the year 2006, what is the difference between the Pupil-teacher ratio(headcount basis) in East Asia (all income levels) and Pupil-teacher ratio(headcount basis) in Dominica?
Your answer should be compact. 0.93. In the year 2006, what is the difference between the Pupil-teacher ratio(headcount basis) in East Asia (all income levels) and Pupil-teacher ratio(headcount basis) in Mexico?
Offer a terse response. -0.47. In the year 2006, what is the difference between the Pupil-teacher ratio(headcount basis) of East Asia (all income levels) and Pupil-teacher ratio(headcount basis) of Panama?
Provide a succinct answer. 1.58. In the year 2006, what is the difference between the Pupil-teacher ratio(headcount basis) of Dominica and Pupil-teacher ratio(headcount basis) of Mexico?
Provide a short and direct response. -1.4. In the year 2006, what is the difference between the Pupil-teacher ratio(headcount basis) of Dominica and Pupil-teacher ratio(headcount basis) of Panama?
Keep it short and to the point. 0.66. In the year 2006, what is the difference between the Pupil-teacher ratio(headcount basis) of Mexico and Pupil-teacher ratio(headcount basis) of Panama?
Your answer should be very brief. 2.06. In the year 2007, what is the difference between the Pupil-teacher ratio(headcount basis) of East Asia (all income levels) and Pupil-teacher ratio(headcount basis) of Dominica?
Offer a very short reply. 0.67. In the year 2007, what is the difference between the Pupil-teacher ratio(headcount basis) in East Asia (all income levels) and Pupil-teacher ratio(headcount basis) in Mexico?
Your answer should be compact. -1.3. In the year 2007, what is the difference between the Pupil-teacher ratio(headcount basis) in East Asia (all income levels) and Pupil-teacher ratio(headcount basis) in Panama?
Provide a succinct answer. 1.14. In the year 2007, what is the difference between the Pupil-teacher ratio(headcount basis) of Dominica and Pupil-teacher ratio(headcount basis) of Mexico?
Provide a succinct answer. -1.96. In the year 2007, what is the difference between the Pupil-teacher ratio(headcount basis) of Dominica and Pupil-teacher ratio(headcount basis) of Panama?
Offer a very short reply. 0.48. In the year 2007, what is the difference between the Pupil-teacher ratio(headcount basis) in Mexico and Pupil-teacher ratio(headcount basis) in Panama?
Your answer should be very brief. 2.44. In the year 2008, what is the difference between the Pupil-teacher ratio(headcount basis) of East Asia (all income levels) and Pupil-teacher ratio(headcount basis) of Dominica?
Ensure brevity in your answer.  1.72. In the year 2008, what is the difference between the Pupil-teacher ratio(headcount basis) of East Asia (all income levels) and Pupil-teacher ratio(headcount basis) of Mexico?
Offer a very short reply. -1.84. In the year 2008, what is the difference between the Pupil-teacher ratio(headcount basis) of East Asia (all income levels) and Pupil-teacher ratio(headcount basis) of Panama?
Your answer should be compact. 0.78. In the year 2008, what is the difference between the Pupil-teacher ratio(headcount basis) in Dominica and Pupil-teacher ratio(headcount basis) in Mexico?
Your response must be concise. -3.56. In the year 2008, what is the difference between the Pupil-teacher ratio(headcount basis) of Dominica and Pupil-teacher ratio(headcount basis) of Panama?
Your answer should be compact. -0.94. In the year 2008, what is the difference between the Pupil-teacher ratio(headcount basis) of Mexico and Pupil-teacher ratio(headcount basis) of Panama?
Provide a succinct answer. 2.62. In the year 2009, what is the difference between the Pupil-teacher ratio(headcount basis) in East Asia (all income levels) and Pupil-teacher ratio(headcount basis) in Dominica?
Give a very brief answer. 2.28. In the year 2009, what is the difference between the Pupil-teacher ratio(headcount basis) of East Asia (all income levels) and Pupil-teacher ratio(headcount basis) of Mexico?
Make the answer very short. -1.59. In the year 2009, what is the difference between the Pupil-teacher ratio(headcount basis) of East Asia (all income levels) and Pupil-teacher ratio(headcount basis) of Panama?
Give a very brief answer. 1.39. In the year 2009, what is the difference between the Pupil-teacher ratio(headcount basis) of Dominica and Pupil-teacher ratio(headcount basis) of Mexico?
Give a very brief answer. -3.87. In the year 2009, what is the difference between the Pupil-teacher ratio(headcount basis) of Dominica and Pupil-teacher ratio(headcount basis) of Panama?
Keep it short and to the point. -0.89. In the year 2009, what is the difference between the Pupil-teacher ratio(headcount basis) of Mexico and Pupil-teacher ratio(headcount basis) of Panama?
Your answer should be compact. 2.98. In the year 2010, what is the difference between the Pupil-teacher ratio(headcount basis) in East Asia (all income levels) and Pupil-teacher ratio(headcount basis) in Dominica?
Offer a very short reply. 2.51. In the year 2010, what is the difference between the Pupil-teacher ratio(headcount basis) in East Asia (all income levels) and Pupil-teacher ratio(headcount basis) in Mexico?
Make the answer very short. -2.16. In the year 2010, what is the difference between the Pupil-teacher ratio(headcount basis) of East Asia (all income levels) and Pupil-teacher ratio(headcount basis) of Panama?
Ensure brevity in your answer.  0.41. In the year 2010, what is the difference between the Pupil-teacher ratio(headcount basis) of Dominica and Pupil-teacher ratio(headcount basis) of Mexico?
Offer a very short reply. -4.67. In the year 2010, what is the difference between the Pupil-teacher ratio(headcount basis) of Dominica and Pupil-teacher ratio(headcount basis) of Panama?
Give a very brief answer. -2.1. In the year 2010, what is the difference between the Pupil-teacher ratio(headcount basis) in Mexico and Pupil-teacher ratio(headcount basis) in Panama?
Your response must be concise. 2.57. In the year 2011, what is the difference between the Pupil-teacher ratio(headcount basis) in East Asia (all income levels) and Pupil-teacher ratio(headcount basis) in Dominica?
Your response must be concise. 3.75. In the year 2011, what is the difference between the Pupil-teacher ratio(headcount basis) of East Asia (all income levels) and Pupil-teacher ratio(headcount basis) of Mexico?
Your answer should be very brief. -1.76. In the year 2011, what is the difference between the Pupil-teacher ratio(headcount basis) in East Asia (all income levels) and Pupil-teacher ratio(headcount basis) in Panama?
Your answer should be very brief. 1.23. In the year 2011, what is the difference between the Pupil-teacher ratio(headcount basis) in Dominica and Pupil-teacher ratio(headcount basis) in Mexico?
Your response must be concise. -5.51. In the year 2011, what is the difference between the Pupil-teacher ratio(headcount basis) of Dominica and Pupil-teacher ratio(headcount basis) of Panama?
Your answer should be very brief. -2.52. In the year 2011, what is the difference between the Pupil-teacher ratio(headcount basis) of Mexico and Pupil-teacher ratio(headcount basis) of Panama?
Ensure brevity in your answer.  2.99. What is the ratio of the Pupil-teacher ratio(headcount basis) in East Asia (all income levels) in 2005 to that in 2006?
Give a very brief answer. 1.03. What is the ratio of the Pupil-teacher ratio(headcount basis) of Dominica in 2005 to that in 2006?
Your response must be concise. 0.92. What is the ratio of the Pupil-teacher ratio(headcount basis) in East Asia (all income levels) in 2005 to that in 2007?
Your answer should be very brief. 1.08. What is the ratio of the Pupil-teacher ratio(headcount basis) in Dominica in 2005 to that in 2007?
Offer a terse response. 0.94. What is the ratio of the Pupil-teacher ratio(headcount basis) in East Asia (all income levels) in 2005 to that in 2008?
Make the answer very short. 1.11. What is the ratio of the Pupil-teacher ratio(headcount basis) in Dominica in 2005 to that in 2008?
Offer a very short reply. 1.04. What is the ratio of the Pupil-teacher ratio(headcount basis) of Mexico in 2005 to that in 2008?
Your answer should be very brief. 0.99. What is the ratio of the Pupil-teacher ratio(headcount basis) in Panama in 2005 to that in 2008?
Provide a succinct answer. 1.02. What is the ratio of the Pupil-teacher ratio(headcount basis) in East Asia (all income levels) in 2005 to that in 2009?
Offer a very short reply. 1.11. What is the ratio of the Pupil-teacher ratio(headcount basis) of Dominica in 2005 to that in 2009?
Your answer should be very brief. 1.09. What is the ratio of the Pupil-teacher ratio(headcount basis) of Mexico in 2005 to that in 2009?
Give a very brief answer. 1.01. What is the ratio of the Pupil-teacher ratio(headcount basis) of Panama in 2005 to that in 2009?
Provide a short and direct response. 1.07. What is the ratio of the Pupil-teacher ratio(headcount basis) of East Asia (all income levels) in 2005 to that in 2010?
Provide a short and direct response. 1.13. What is the ratio of the Pupil-teacher ratio(headcount basis) of Dominica in 2005 to that in 2010?
Provide a short and direct response. 1.14. What is the ratio of the Pupil-teacher ratio(headcount basis) of East Asia (all income levels) in 2005 to that in 2011?
Ensure brevity in your answer.  1.12. What is the ratio of the Pupil-teacher ratio(headcount basis) of Dominica in 2005 to that in 2011?
Your response must be concise. 1.24. What is the ratio of the Pupil-teacher ratio(headcount basis) in Mexico in 2005 to that in 2011?
Ensure brevity in your answer.  1.01. What is the ratio of the Pupil-teacher ratio(headcount basis) in Panama in 2005 to that in 2011?
Offer a terse response. 1.06. What is the ratio of the Pupil-teacher ratio(headcount basis) of East Asia (all income levels) in 2006 to that in 2007?
Offer a terse response. 1.04. What is the ratio of the Pupil-teacher ratio(headcount basis) of Dominica in 2006 to that in 2007?
Make the answer very short. 1.03. What is the ratio of the Pupil-teacher ratio(headcount basis) in Mexico in 2006 to that in 2007?
Provide a short and direct response. 1. What is the ratio of the Pupil-teacher ratio(headcount basis) of Panama in 2006 to that in 2007?
Offer a terse response. 1.02. What is the ratio of the Pupil-teacher ratio(headcount basis) of East Asia (all income levels) in 2006 to that in 2008?
Provide a short and direct response. 1.07. What is the ratio of the Pupil-teacher ratio(headcount basis) in Dominica in 2006 to that in 2008?
Offer a terse response. 1.14. What is the ratio of the Pupil-teacher ratio(headcount basis) of Mexico in 2006 to that in 2008?
Your response must be concise. 0.99. What is the ratio of the Pupil-teacher ratio(headcount basis) of Panama in 2006 to that in 2008?
Your answer should be very brief. 1.03. What is the ratio of the Pupil-teacher ratio(headcount basis) in East Asia (all income levels) in 2006 to that in 2009?
Your response must be concise. 1.08. What is the ratio of the Pupil-teacher ratio(headcount basis) in Dominica in 2006 to that in 2009?
Ensure brevity in your answer.  1.19. What is the ratio of the Pupil-teacher ratio(headcount basis) of Mexico in 2006 to that in 2009?
Make the answer very short. 1.01. What is the ratio of the Pupil-teacher ratio(headcount basis) of Panama in 2006 to that in 2009?
Provide a succinct answer. 1.08. What is the ratio of the Pupil-teacher ratio(headcount basis) in East Asia (all income levels) in 2006 to that in 2010?
Keep it short and to the point. 1.1. What is the ratio of the Pupil-teacher ratio(headcount basis) of Dominica in 2006 to that in 2010?
Keep it short and to the point. 1.24. What is the ratio of the Pupil-teacher ratio(headcount basis) of Panama in 2006 to that in 2010?
Offer a very short reply. 1.03. What is the ratio of the Pupil-teacher ratio(headcount basis) of East Asia (all income levels) in 2006 to that in 2011?
Offer a very short reply. 1.09. What is the ratio of the Pupil-teacher ratio(headcount basis) of Dominica in 2006 to that in 2011?
Make the answer very short. 1.35. What is the ratio of the Pupil-teacher ratio(headcount basis) in Mexico in 2006 to that in 2011?
Provide a succinct answer. 1.01. What is the ratio of the Pupil-teacher ratio(headcount basis) in Panama in 2006 to that in 2011?
Make the answer very short. 1.07. What is the ratio of the Pupil-teacher ratio(headcount basis) in East Asia (all income levels) in 2007 to that in 2008?
Offer a very short reply. 1.03. What is the ratio of the Pupil-teacher ratio(headcount basis) of Dominica in 2007 to that in 2008?
Provide a short and direct response. 1.1. What is the ratio of the Pupil-teacher ratio(headcount basis) in Mexico in 2007 to that in 2008?
Provide a succinct answer. 0.99. What is the ratio of the Pupil-teacher ratio(headcount basis) in Panama in 2007 to that in 2008?
Provide a succinct answer. 1.01. What is the ratio of the Pupil-teacher ratio(headcount basis) in East Asia (all income levels) in 2007 to that in 2009?
Your answer should be compact. 1.04. What is the ratio of the Pupil-teacher ratio(headcount basis) of Dominica in 2007 to that in 2009?
Provide a short and direct response. 1.16. What is the ratio of the Pupil-teacher ratio(headcount basis) in Mexico in 2007 to that in 2009?
Offer a terse response. 1.02. What is the ratio of the Pupil-teacher ratio(headcount basis) of Panama in 2007 to that in 2009?
Provide a short and direct response. 1.06. What is the ratio of the Pupil-teacher ratio(headcount basis) in East Asia (all income levels) in 2007 to that in 2010?
Make the answer very short. 1.06. What is the ratio of the Pupil-teacher ratio(headcount basis) of Dominica in 2007 to that in 2010?
Your answer should be very brief. 1.2. What is the ratio of the Pupil-teacher ratio(headcount basis) of Panama in 2007 to that in 2010?
Ensure brevity in your answer.  1.01. What is the ratio of the Pupil-teacher ratio(headcount basis) of East Asia (all income levels) in 2007 to that in 2011?
Provide a succinct answer. 1.04. What is the ratio of the Pupil-teacher ratio(headcount basis) of Dominica in 2007 to that in 2011?
Offer a terse response. 1.31. What is the ratio of the Pupil-teacher ratio(headcount basis) of Mexico in 2007 to that in 2011?
Offer a very short reply. 1.01. What is the ratio of the Pupil-teacher ratio(headcount basis) of Panama in 2007 to that in 2011?
Provide a succinct answer. 1.05. What is the ratio of the Pupil-teacher ratio(headcount basis) in East Asia (all income levels) in 2008 to that in 2009?
Your answer should be compact. 1.01. What is the ratio of the Pupil-teacher ratio(headcount basis) in Dominica in 2008 to that in 2009?
Offer a very short reply. 1.05. What is the ratio of the Pupil-teacher ratio(headcount basis) in Mexico in 2008 to that in 2009?
Offer a very short reply. 1.02. What is the ratio of the Pupil-teacher ratio(headcount basis) of Panama in 2008 to that in 2009?
Your answer should be compact. 1.05. What is the ratio of the Pupil-teacher ratio(headcount basis) in East Asia (all income levels) in 2008 to that in 2010?
Your answer should be compact. 1.03. What is the ratio of the Pupil-teacher ratio(headcount basis) of Dominica in 2008 to that in 2010?
Your answer should be compact. 1.09. What is the ratio of the Pupil-teacher ratio(headcount basis) in Panama in 2008 to that in 2010?
Make the answer very short. 1. What is the ratio of the Pupil-teacher ratio(headcount basis) of Dominica in 2008 to that in 2011?
Give a very brief answer. 1.19. What is the ratio of the Pupil-teacher ratio(headcount basis) in Mexico in 2008 to that in 2011?
Ensure brevity in your answer.  1.02. What is the ratio of the Pupil-teacher ratio(headcount basis) of Panama in 2008 to that in 2011?
Ensure brevity in your answer.  1.05. What is the ratio of the Pupil-teacher ratio(headcount basis) of East Asia (all income levels) in 2009 to that in 2010?
Ensure brevity in your answer.  1.02. What is the ratio of the Pupil-teacher ratio(headcount basis) in Dominica in 2009 to that in 2010?
Your answer should be very brief. 1.04. What is the ratio of the Pupil-teacher ratio(headcount basis) in Panama in 2009 to that in 2010?
Your answer should be very brief. 0.96. What is the ratio of the Pupil-teacher ratio(headcount basis) in East Asia (all income levels) in 2009 to that in 2011?
Give a very brief answer. 1.01. What is the ratio of the Pupil-teacher ratio(headcount basis) of Dominica in 2009 to that in 2011?
Your response must be concise. 1.13. What is the ratio of the Pupil-teacher ratio(headcount basis) of Dominica in 2010 to that in 2011?
Keep it short and to the point. 1.09. What is the ratio of the Pupil-teacher ratio(headcount basis) of Mexico in 2010 to that in 2011?
Offer a terse response. 1.01. What is the ratio of the Pupil-teacher ratio(headcount basis) of Panama in 2010 to that in 2011?
Ensure brevity in your answer.  1.04. What is the difference between the highest and the second highest Pupil-teacher ratio(headcount basis) of East Asia (all income levels)?
Ensure brevity in your answer.  0.51. What is the difference between the highest and the second highest Pupil-teacher ratio(headcount basis) in Dominica?
Provide a succinct answer. 0.48. What is the difference between the highest and the second highest Pupil-teacher ratio(headcount basis) of Mexico?
Offer a terse response. 0.09. What is the difference between the highest and the second highest Pupil-teacher ratio(headcount basis) of Panama?
Ensure brevity in your answer.  0.14. What is the difference between the highest and the lowest Pupil-teacher ratio(headcount basis) of East Asia (all income levels)?
Your answer should be very brief. 2.12. What is the difference between the highest and the lowest Pupil-teacher ratio(headcount basis) of Dominica?
Keep it short and to the point. 4.27. What is the difference between the highest and the lowest Pupil-teacher ratio(headcount basis) in Mexico?
Your response must be concise. 0.37. What is the difference between the highest and the lowest Pupil-teacher ratio(headcount basis) of Panama?
Give a very brief answer. 1.12. 